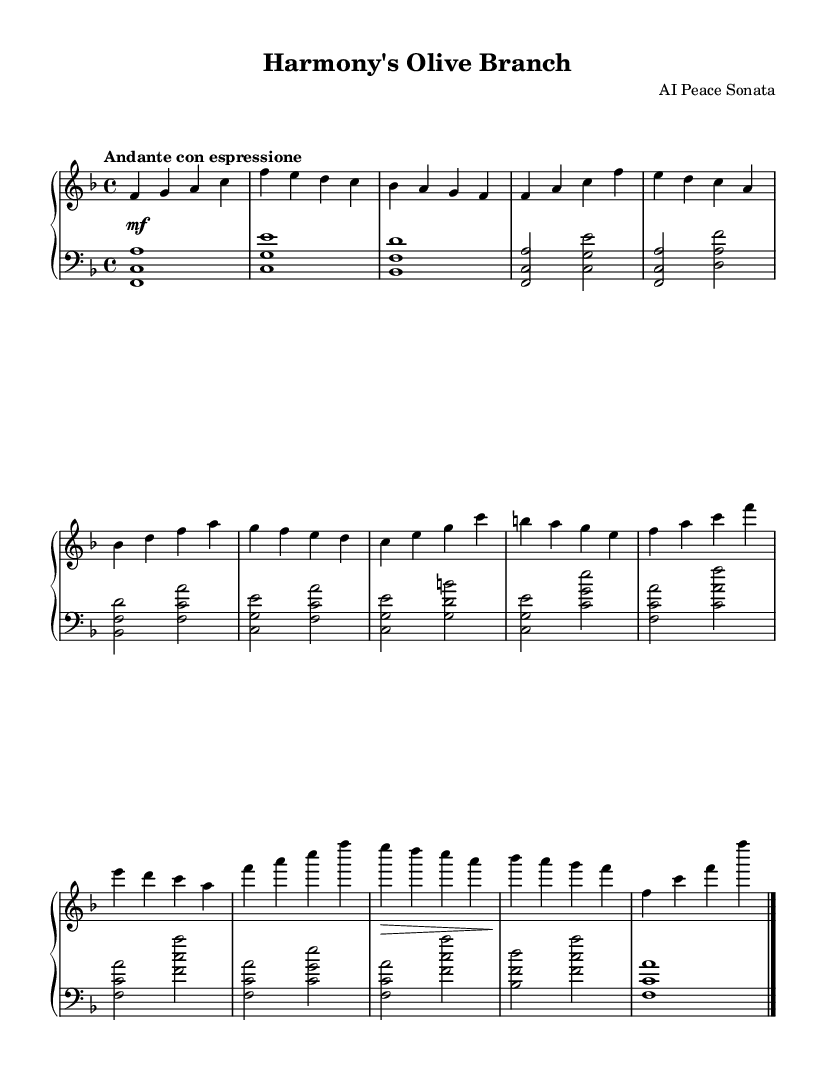What is the key signature of this music? The key signature, indicated at the beginning, shows one flat, which is B flat. This means the piece is in F major.
Answer: F major What is the time signature of this piece? The time signature, appearing at the start of the sheet music, is shown as a fraction of four beats per measure. This indicates there are four beats in each measure.
Answer: Four four What is the tempo marking? The tempo marking is provided in Italian, situated above the staff at the beginning, indicating the desired speed and expression style for the performance. Here it reads "Andante con espressione."
Answer: Andante con espressione How many themes are present in the composition? By analyzing the structure of the music, two distinct themes (Theme A and Theme B) can be identified within the piece. This is evidenced by the specific sections where these themes are introduced in the music.
Answer: Two themes What is the dynamic marking at the beginning? The dynamics are indicated at the start of the piece and show a marking, which instructs the performer on the volume, starting with a "mezzo forte," meaning moderately loud.
Answer: Mezzo forte Which section contains the introduction? The initial measures of the music are specifically labeled as the introduction, where the motifs begin to establish the tone before the main themes are introduced.
Answer: The first section In which part does Theme A first appear? Theme A is first introduced after the introduction section and is marked explicitly in the music sheet, beginning with the notes that define its character.
Answer: After the introduction 